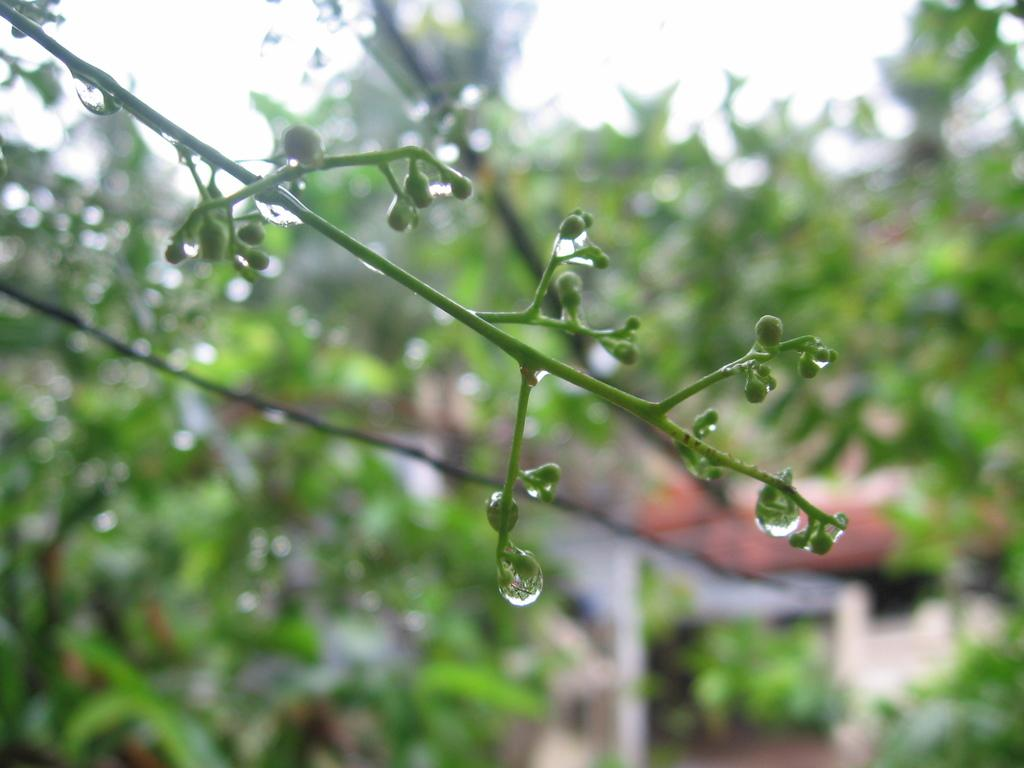What is present on the buds of the tree in the image? There are droplets of water on the buds of a tree. What can be seen in the background of the image? There are trees in the background of the image. What type of glove is being used to create the droplets of water on the tree in the image? There is no glove present in the image, and the droplets of water are naturally occurring. 